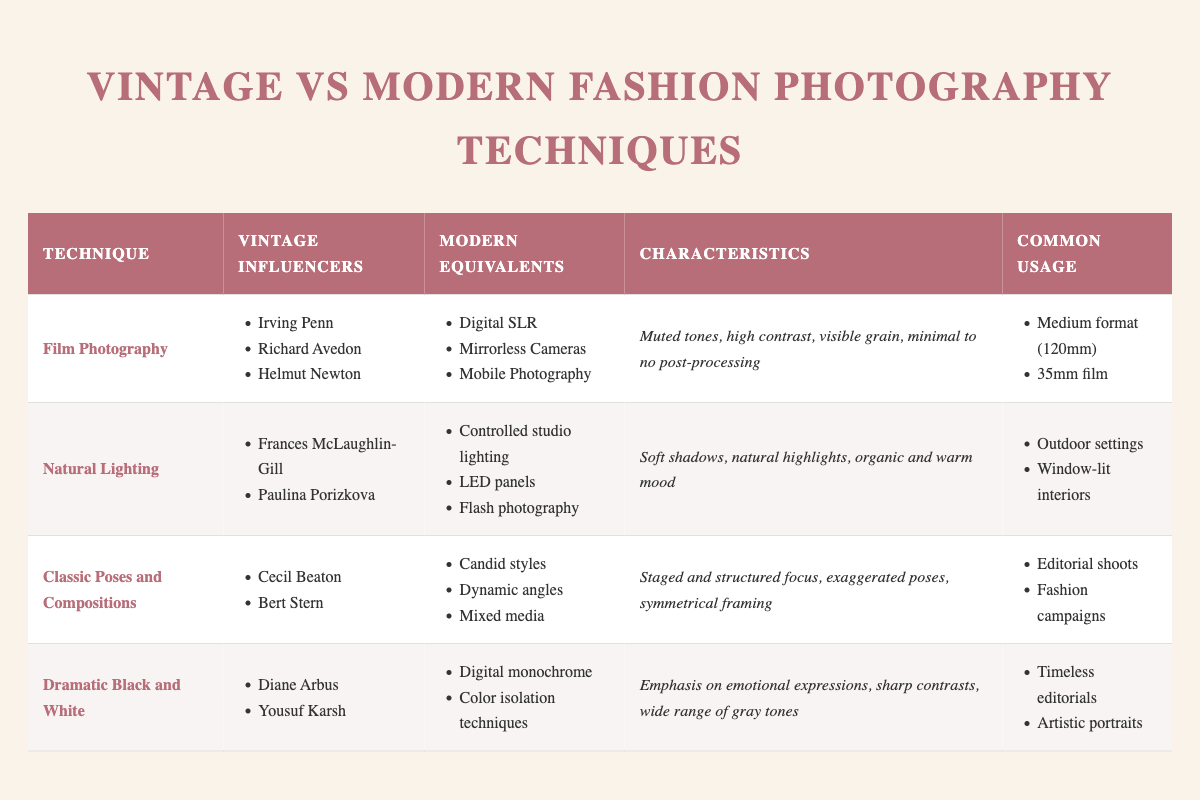What are some modern equivalents of film photography? The table lists "Digital SLR," "Mirrorless Cameras," and "Mobile Photography" as modern equivalents of film photography under the relevant section.
Answer: Digital SLR, Mirrorless Cameras, Mobile Photography Which vintage influencer is associated with dramatic black and white photography? According to the table, "Diane Arbus" and "Yousuf Karsh" are the vintage influencers associated with dramatic black and white photography.
Answer: Diane Arbus, Yousuf Karsh How many photography techniques are listed in the table? To find the total, count the number of techniques enumerated in the table. There are four listed: Film Photography, Natural Lighting, Classic Poses and Compositions, and Dramatic Black and White.
Answer: 4 Is soft shadows a characteristic of natural lighting? The table clearly states that soft shadows are a characteristic associated with natural lighting, making this statement true.
Answer: Yes Which technique emphasizes emotional expressions and uses sharp contrasts? The table specifies that the "Dramatic Black and White" technique emphasizes emotional expressions and features sharp contrasts, indicating that this is the correct technique.
Answer: Dramatic Black and White What are the common locations for natural lighting photography? From the table, the common locations for natural lighting photography are "Outdoor settings" and "Window-lit interiors," which can be found in the third column.
Answer: Outdoor settings, Window-lit interiors Which technique is associated with exaggerated poses? The table shows that "Classic Poses and Compositions" is associated with exaggerated poses as part of its characteristics.
Answer: Classic Poses and Compositions If we compare the characteristics of film photography and natural lighting, what is the key difference regarding post-processing? In the table, film photography is characterized by "Minimal to none" post-processing, while natural lighting does not specify post-processing characteristics, indicating that post-processing is noticeably absent in film photography.
Answer: Minimal to none What modern techniques can be compared with classic poses and compositions? The table equates classic poses and compositions with "Candid styles," "Dynamic angles," and "Mixed media" as modern counterparts, allowing for an understanding of how these techniques have evolved.
Answer: Candid styles, Dynamic angles, Mixed media 